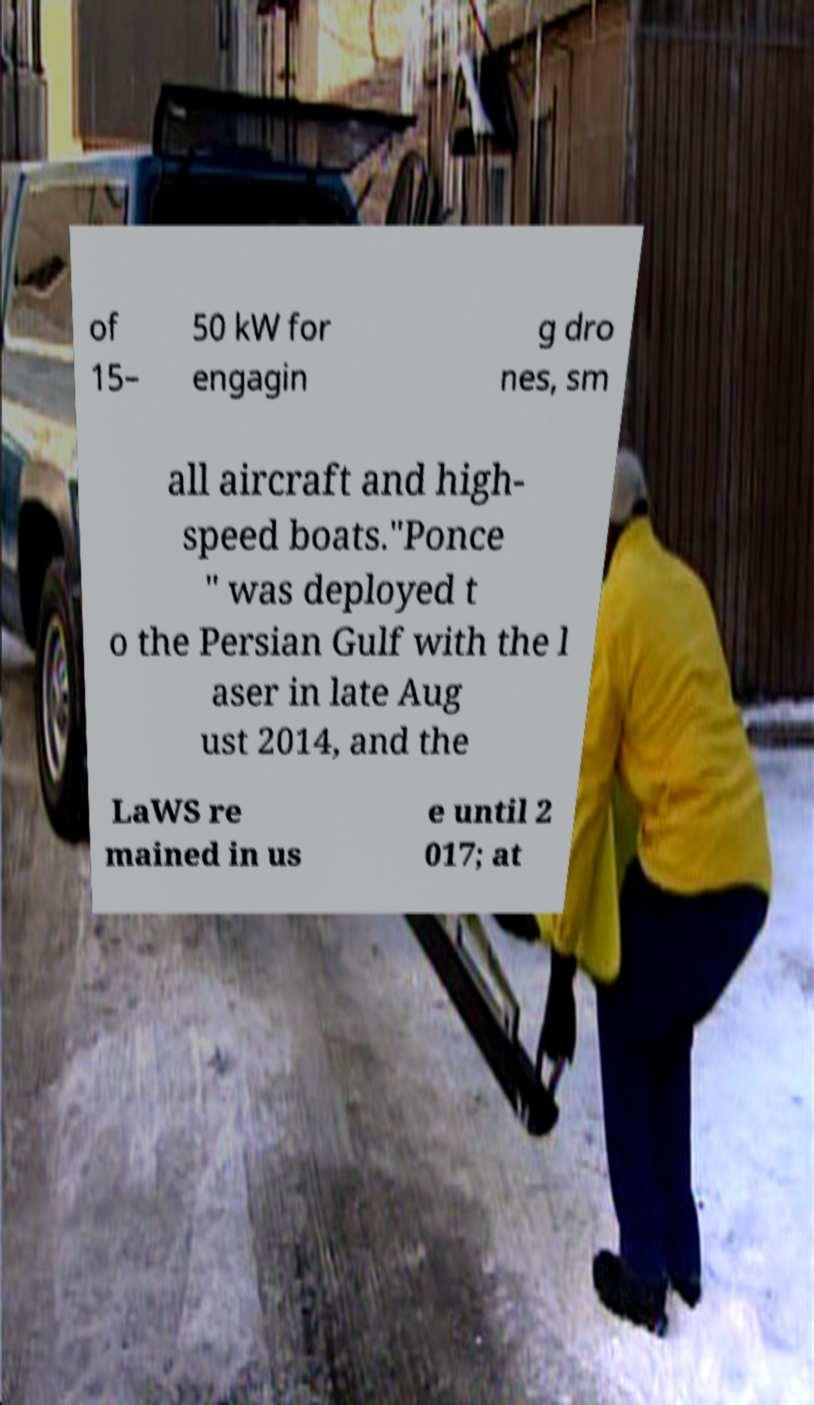Please read and relay the text visible in this image. What does it say? of 15– 50 kW for engagin g dro nes, sm all aircraft and high- speed boats."Ponce " was deployed t o the Persian Gulf with the l aser in late Aug ust 2014, and the LaWS re mained in us e until 2 017; at 